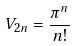Convert formula to latex. <formula><loc_0><loc_0><loc_500><loc_500>V _ { 2 n } = \frac { \pi ^ { n } } { n ! }</formula> 